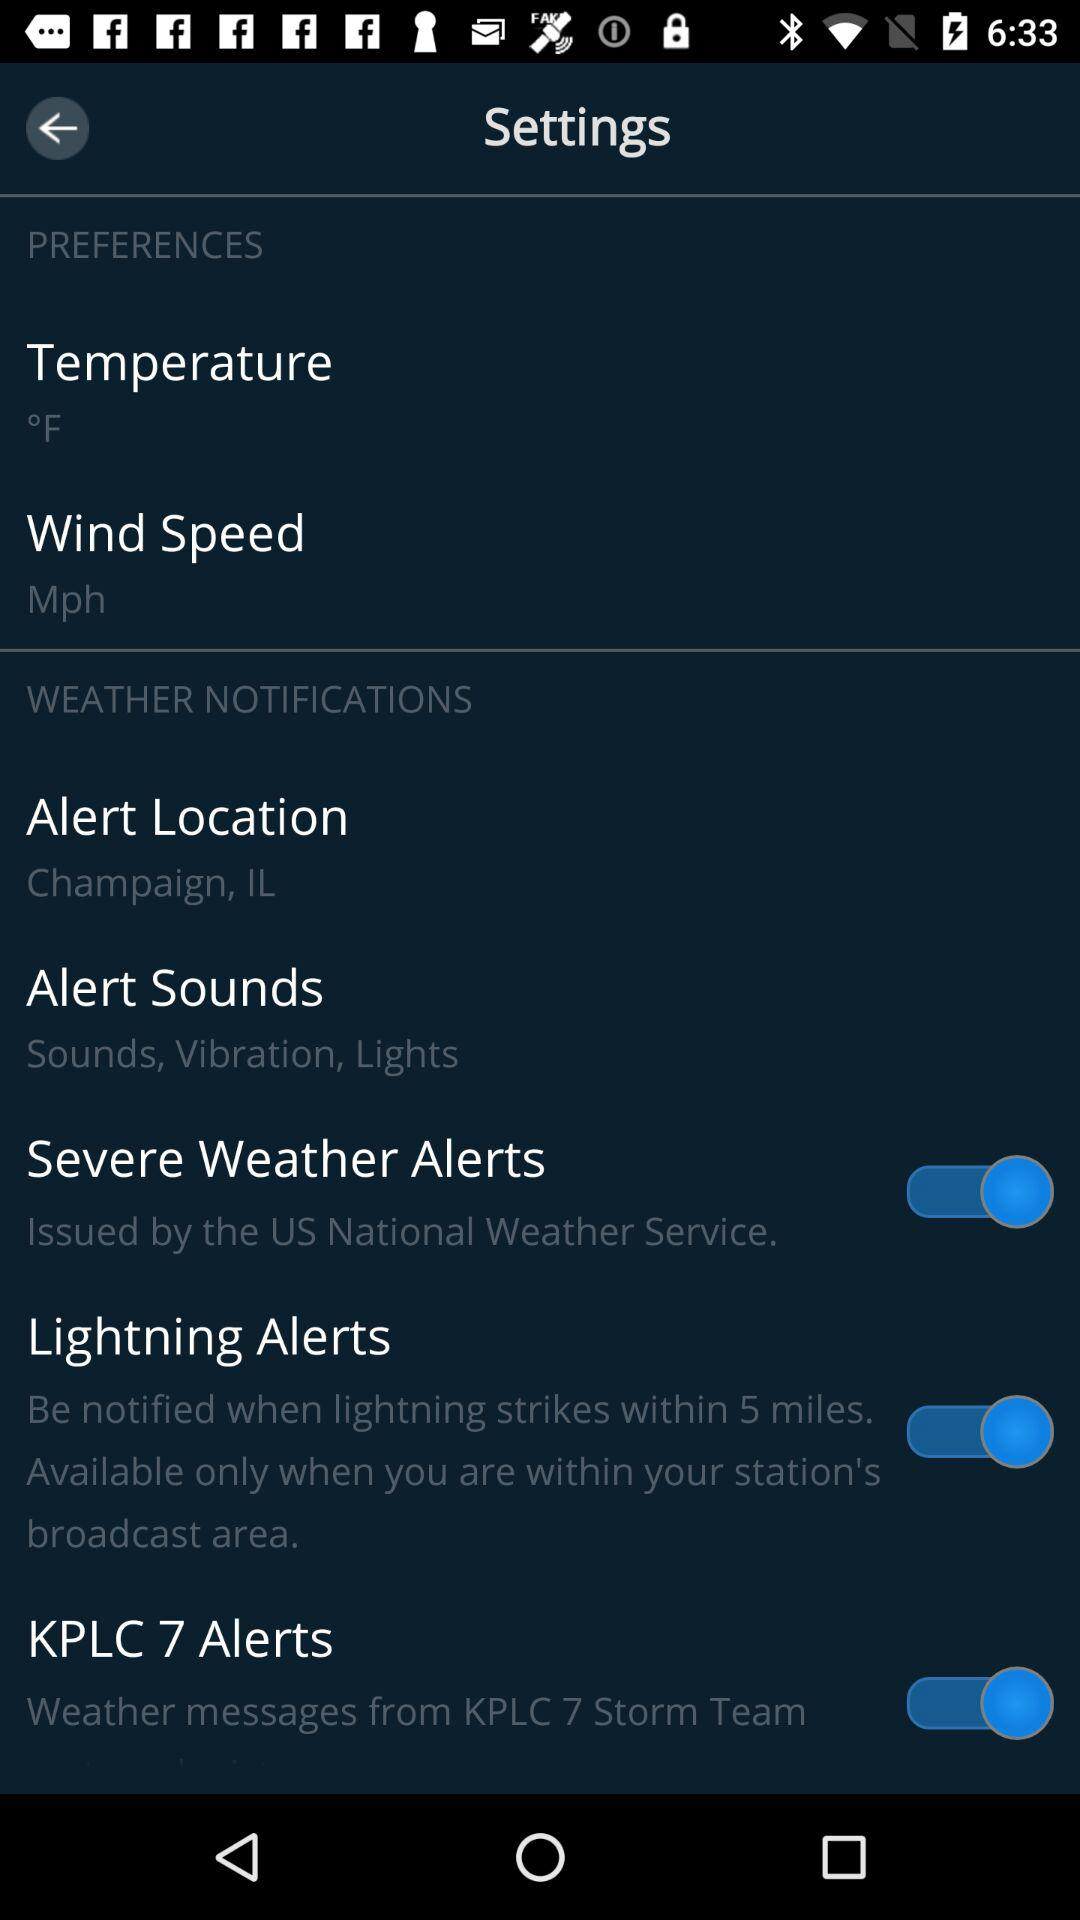What is the status of the wind speed?
When the provided information is insufficient, respond with <no answer>. <no answer> 